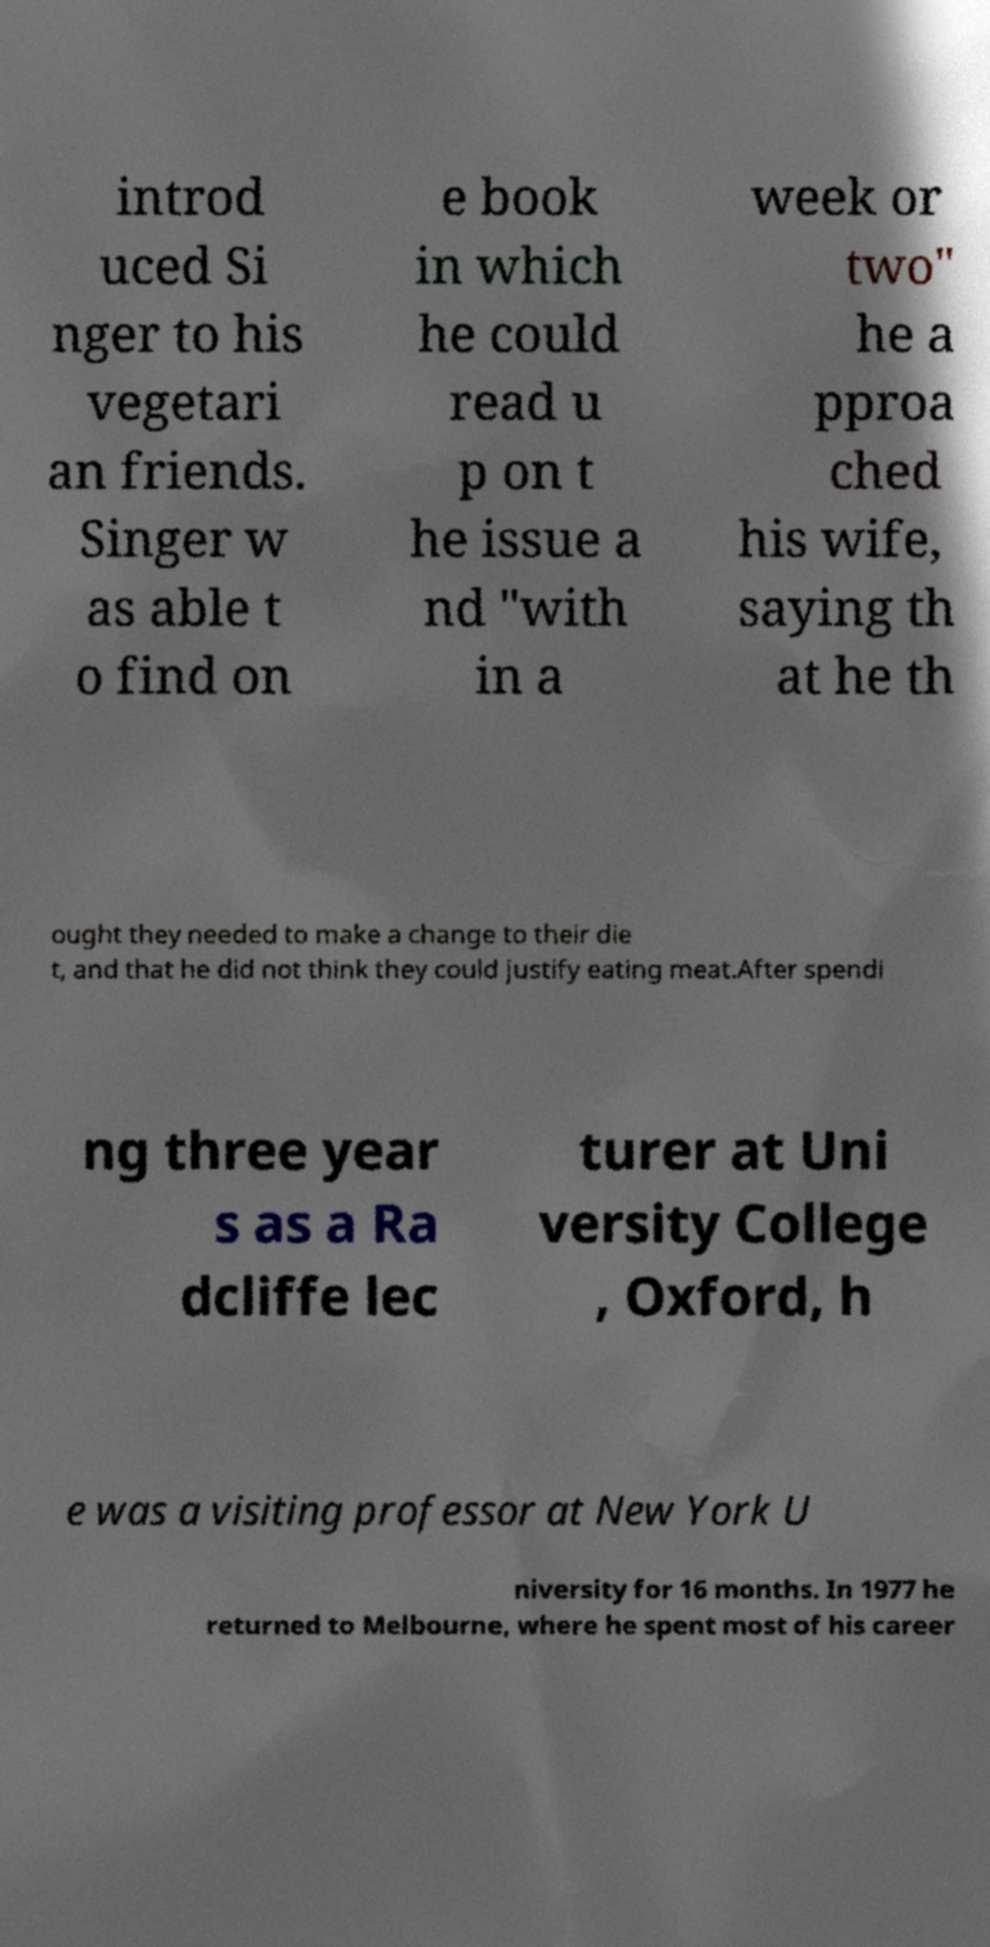There's text embedded in this image that I need extracted. Can you transcribe it verbatim? introd uced Si nger to his vegetari an friends. Singer w as able t o find on e book in which he could read u p on t he issue a nd "with in a week or two" he a pproa ched his wife, saying th at he th ought they needed to make a change to their die t, and that he did not think they could justify eating meat.After spendi ng three year s as a Ra dcliffe lec turer at Uni versity College , Oxford, h e was a visiting professor at New York U niversity for 16 months. In 1977 he returned to Melbourne, where he spent most of his career 